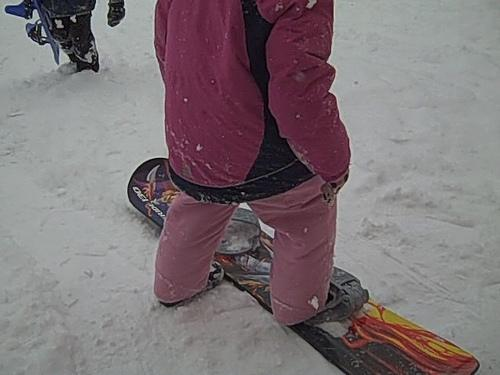How would it be if she tried to snowboard assis? difficult 